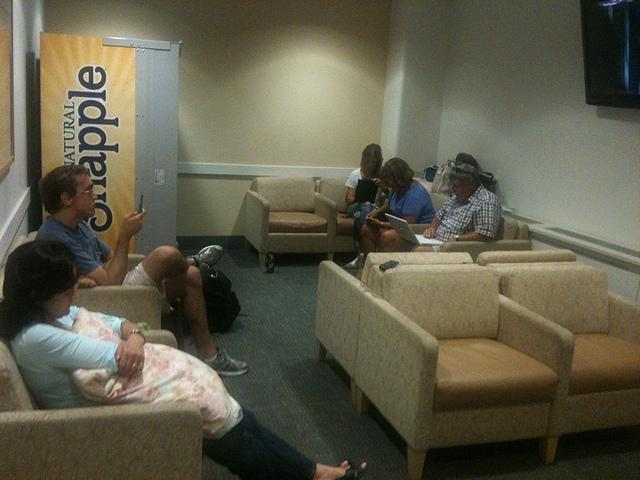What sort of beverages are most readily available here?

Choices:
A) hot chocolate
B) icees
C) coffee
D) iced tea iced tea 